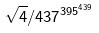<formula> <loc_0><loc_0><loc_500><loc_500>\sqrt { 4 } / 4 3 7 ^ { 3 9 5 ^ { 4 3 9 } }</formula> 